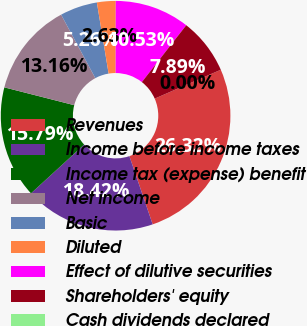<chart> <loc_0><loc_0><loc_500><loc_500><pie_chart><fcel>Revenues<fcel>Income before income taxes<fcel>Income tax (expense) benefit<fcel>Net income<fcel>Basic<fcel>Diluted<fcel>Effect of dilutive securities<fcel>Shareholders' equity<fcel>Cash dividends declared<nl><fcel>26.32%<fcel>18.42%<fcel>15.79%<fcel>13.16%<fcel>5.26%<fcel>2.63%<fcel>10.53%<fcel>7.89%<fcel>0.0%<nl></chart> 